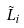<formula> <loc_0><loc_0><loc_500><loc_500>\tilde { L } _ { i }</formula> 